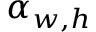<formula> <loc_0><loc_0><loc_500><loc_500>\alpha _ { w , h }</formula> 